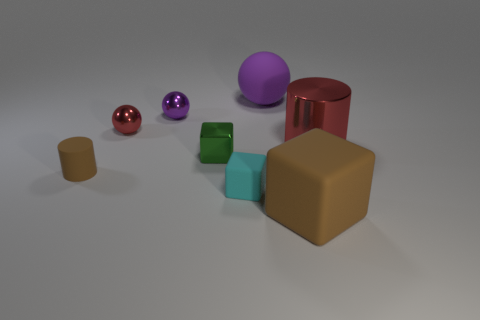There is a cyan rubber thing; how many brown matte things are on the right side of it?
Keep it short and to the point. 1. What material is the big thing that is behind the small cyan rubber block and left of the big red thing?
Make the answer very short. Rubber. What number of matte spheres are the same size as the metal cylinder?
Provide a short and direct response. 1. What color is the matte cube to the right of the large rubber thing that is behind the tiny red shiny thing?
Offer a terse response. Brown. Are any big red metallic spheres visible?
Your answer should be compact. No. Do the large brown matte object and the cyan rubber thing have the same shape?
Offer a very short reply. Yes. The object that is the same color as the tiny matte cylinder is what size?
Your response must be concise. Large. There is a rubber thing behind the tiny red ball; how many rubber cylinders are on the left side of it?
Your answer should be very brief. 1. How many things are both behind the cyan cube and on the right side of the matte ball?
Your answer should be compact. 1. What number of things are cyan balls or brown things in front of the tiny cyan matte cube?
Provide a succinct answer. 1. 